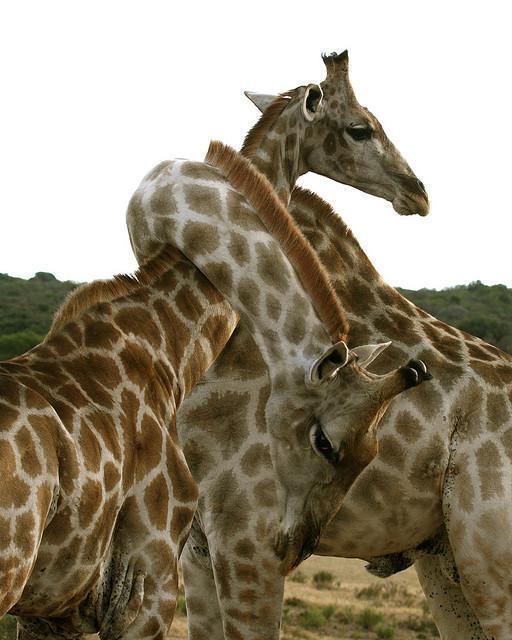How many giraffes are in the photo?
Give a very brief answer. 2. 